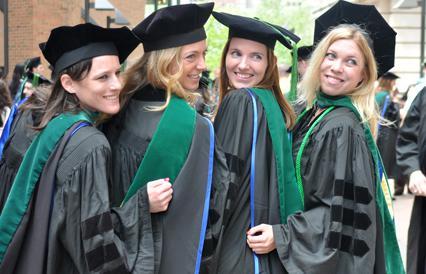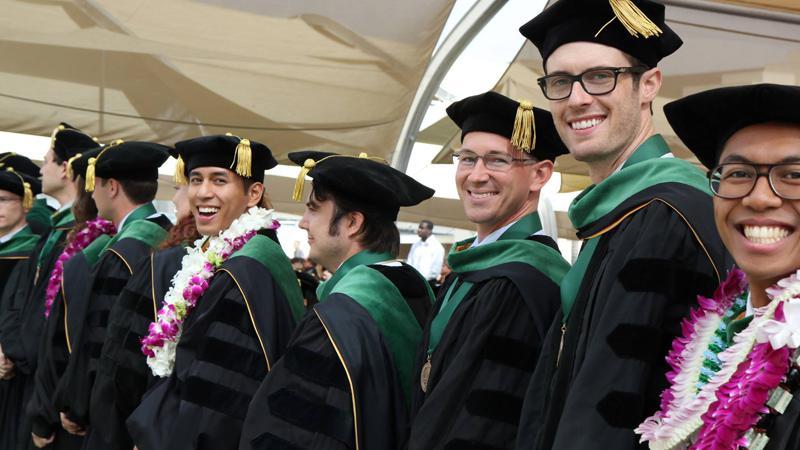The first image is the image on the left, the second image is the image on the right. Assess this claim about the two images: "Blue seats are shown in the auditorium behind the graduates in one of the images.". Correct or not? Answer yes or no. No. 